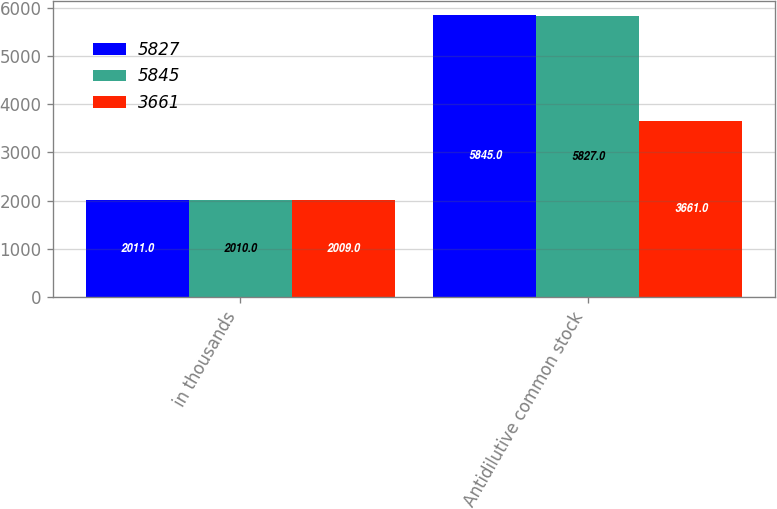<chart> <loc_0><loc_0><loc_500><loc_500><stacked_bar_chart><ecel><fcel>in thousands<fcel>Antidilutive common stock<nl><fcel>5827<fcel>2011<fcel>5845<nl><fcel>5845<fcel>2010<fcel>5827<nl><fcel>3661<fcel>2009<fcel>3661<nl></chart> 